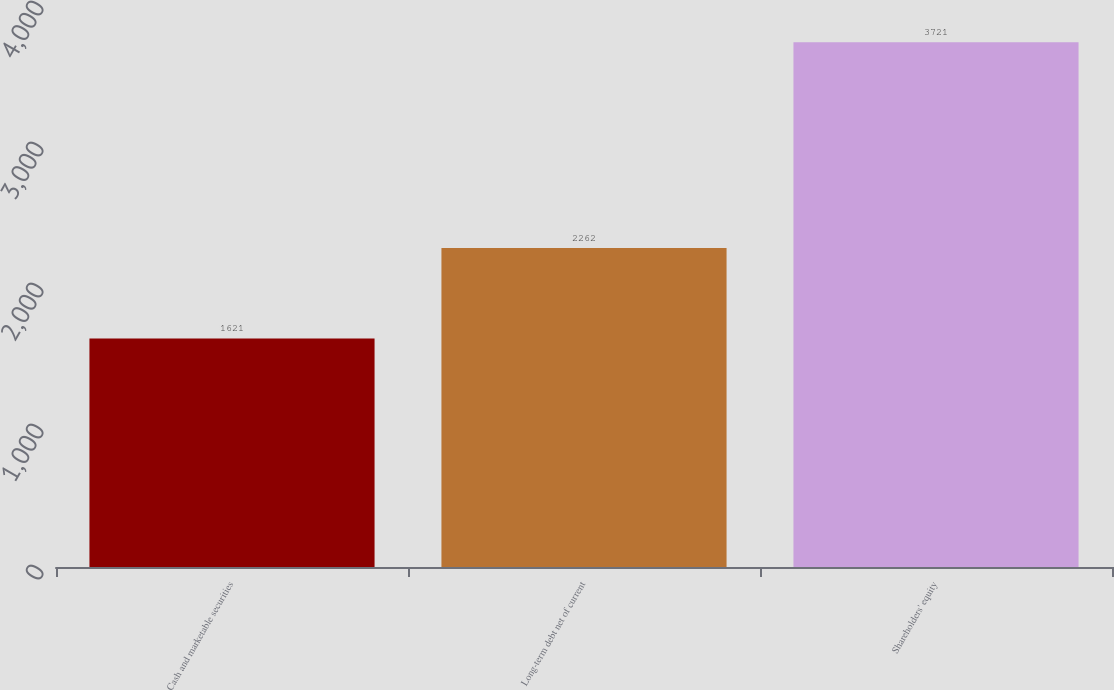<chart> <loc_0><loc_0><loc_500><loc_500><bar_chart><fcel>Cash and marketable securities<fcel>Long-term debt net of current<fcel>Shareholders' equity<nl><fcel>1621<fcel>2262<fcel>3721<nl></chart> 